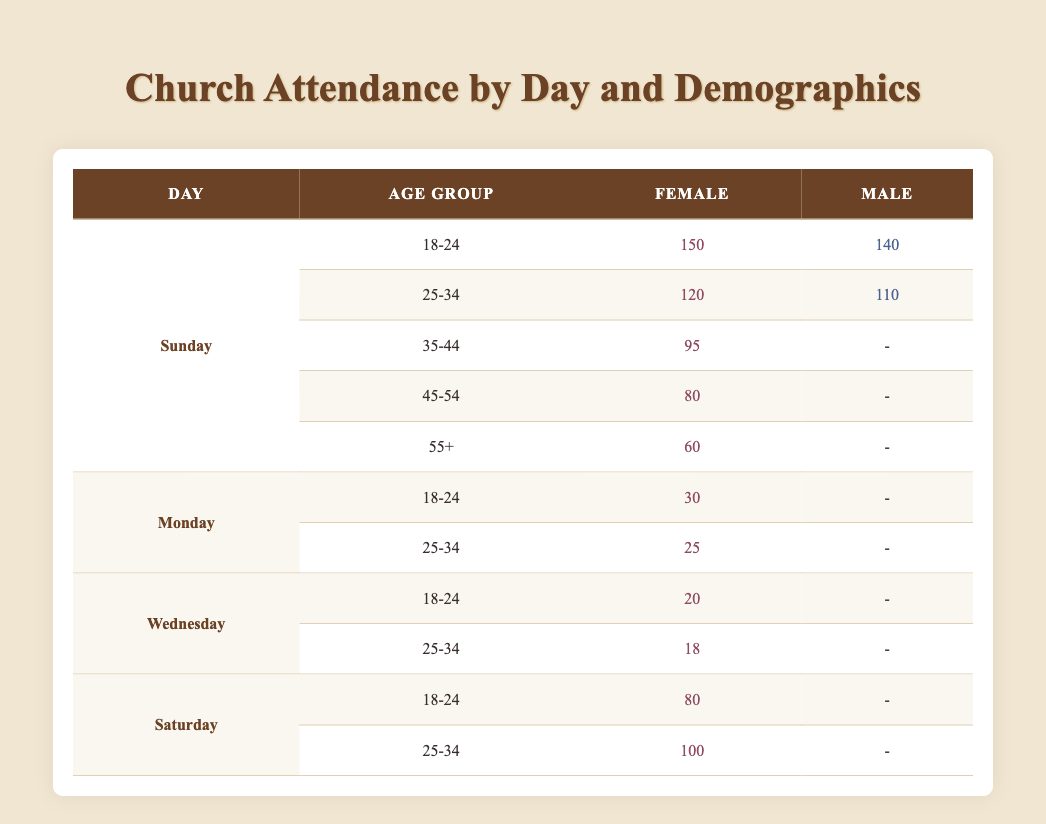What is the attendance count for females aged 25-34 on Sunday? The table shows that for Sunday under the age group of 25-34, the attendance count for females is 120.
Answer: 120 What is the attendance count for males aged 18-24 on Wednesday? In the table, there is no data provided for males aged 18-24 on Wednesday, indicated by a dash (-).
Answer: 0 On which day does the age group 55+ have the highest attendance for females? The table lists females aged 55+ with an attendance count of 60 on Sunday, which is the only day they are recorded. Therefore, Sunday is when their attendance is highest.
Answer: Sunday What is the total attendance for females aged 18-24 across all days? The attendance counts for females aged 18-24 on different days are: Sunday (150), Monday (30), Wednesday (20), and Saturday (80). Summing these gives 150 + 30 + 20 + 80 = 280.
Answer: 280 Is the attendance for females aged 45-54 higher than the attendance for males aged 25-34 on Sunday? The female attendance aged 45-54 on Sunday is 80, while male attendance for the same day and age group is 110. Since 80 is less than 110, the statement is false.
Answer: No What is the average attendance for females on Saturday? Looking at Saturday, the attendance counts for females are: 80 (age 18-24) and 100 (age 25-34). Summing these gives 180, and since there are 2 age groups, the average is 180/2 = 90.
Answer: 90 Is there any day where males aged 35-44 have attendance recorded? The table does not show any attendance for males in the 35-44 age group on any day, indicated by dashes (-) across all relevant rows.
Answer: No Which age group has the lowest total attendance for females? The total attendance for females by age group is as follows: 18-24 (150 + 30 + 20 + 80 = 280), 25-34 (120 + 25 + 18 + 100 = 263), 35-44 (95), 45-54 (80), and 55+ (60). The lowest total attendance is for the age group 55+, which has 60.
Answer: 55+ 